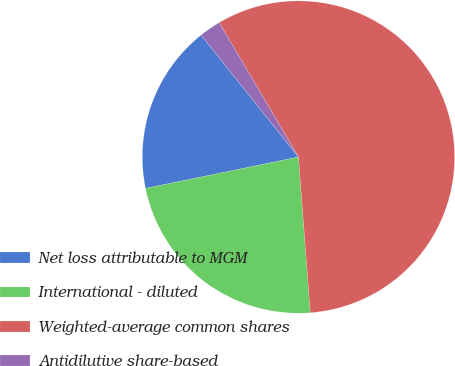<chart> <loc_0><loc_0><loc_500><loc_500><pie_chart><fcel>Net loss attributable to MGM<fcel>International - diluted<fcel>Weighted-average common shares<fcel>Antidilutive share-based<nl><fcel>17.49%<fcel>22.99%<fcel>57.28%<fcel>2.25%<nl></chart> 